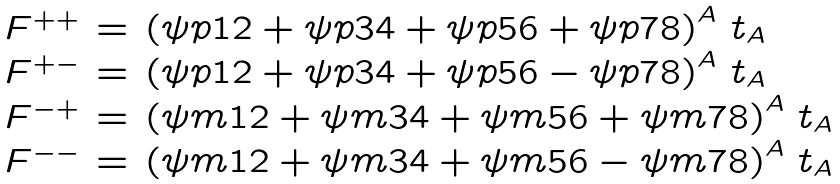<formula> <loc_0><loc_0><loc_500><loc_500>\begin{array} { l l l } F ^ { + + } & = & \left ( \psi p { 1 2 } + \psi p { 3 4 } + \psi p { 5 6 } + \psi p { 7 8 } \right ) ^ { A } \, t _ { A } \\ F ^ { + - } & = & \left ( \psi p { 1 2 } + \psi p { 3 4 } + \psi p { 5 6 } - \psi p { 7 8 } \right ) ^ { A } \, t _ { A } \\ F ^ { - + } & = & \left ( \psi m { 1 2 } + \psi m { 3 4 } + \psi m { 5 6 } + \psi m { 7 8 } \right ) ^ { A } \, t _ { A } \\ F ^ { - - } & = & \left ( \psi m { 1 2 } + \psi m { 3 4 } + \psi m { 5 6 } - \psi m { 7 8 } \right ) ^ { A } \, t _ { A } \end{array}</formula> 